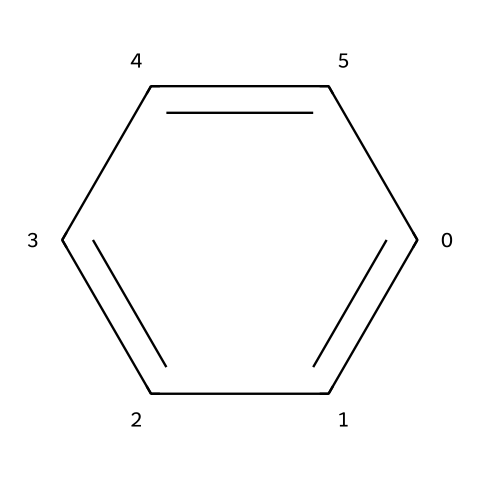What is the name of this chemical structure? The provided SMILES representation corresponds to the structure of benzene, which is a well-known aromatic hydrocarbon.
Answer: benzene How many carbon atoms are present in the structure? Analyzing the SMILES representation reveals six carbon atoms in a ring configuration, typical for benzene.
Answer: six What type of bonding is found in this chemical? The chemical features alternating double bonds in a cyclic structure, characteristic of aromatic compounds, indicating resonance stabilization.
Answer: aromatic Is this chemical considered a flammable liquid? Benzene is known to be flammable due to its low flash point and ability to easily ignite, which aligns with its classification as a flammable liquid.
Answer: yes What is the primary use of benzene in gasoline? Benzene is commonly used as an additive in gasoline to improve octane ratings and enhance fuel performance.
Answer: octane booster How does the chemical structure influence its combustibility? The stability provided by the cyclic structure of benzene allows it to readily participate in combustion reactions, making it highly combustible.
Answer: readily combusts What is the effect of benzene in environmental terms? Benzene is recognized as an environmental pollutant due to its carcinogenic properties and potential to contaminate air and water, raising health concerns.
Answer: carcinogenic 